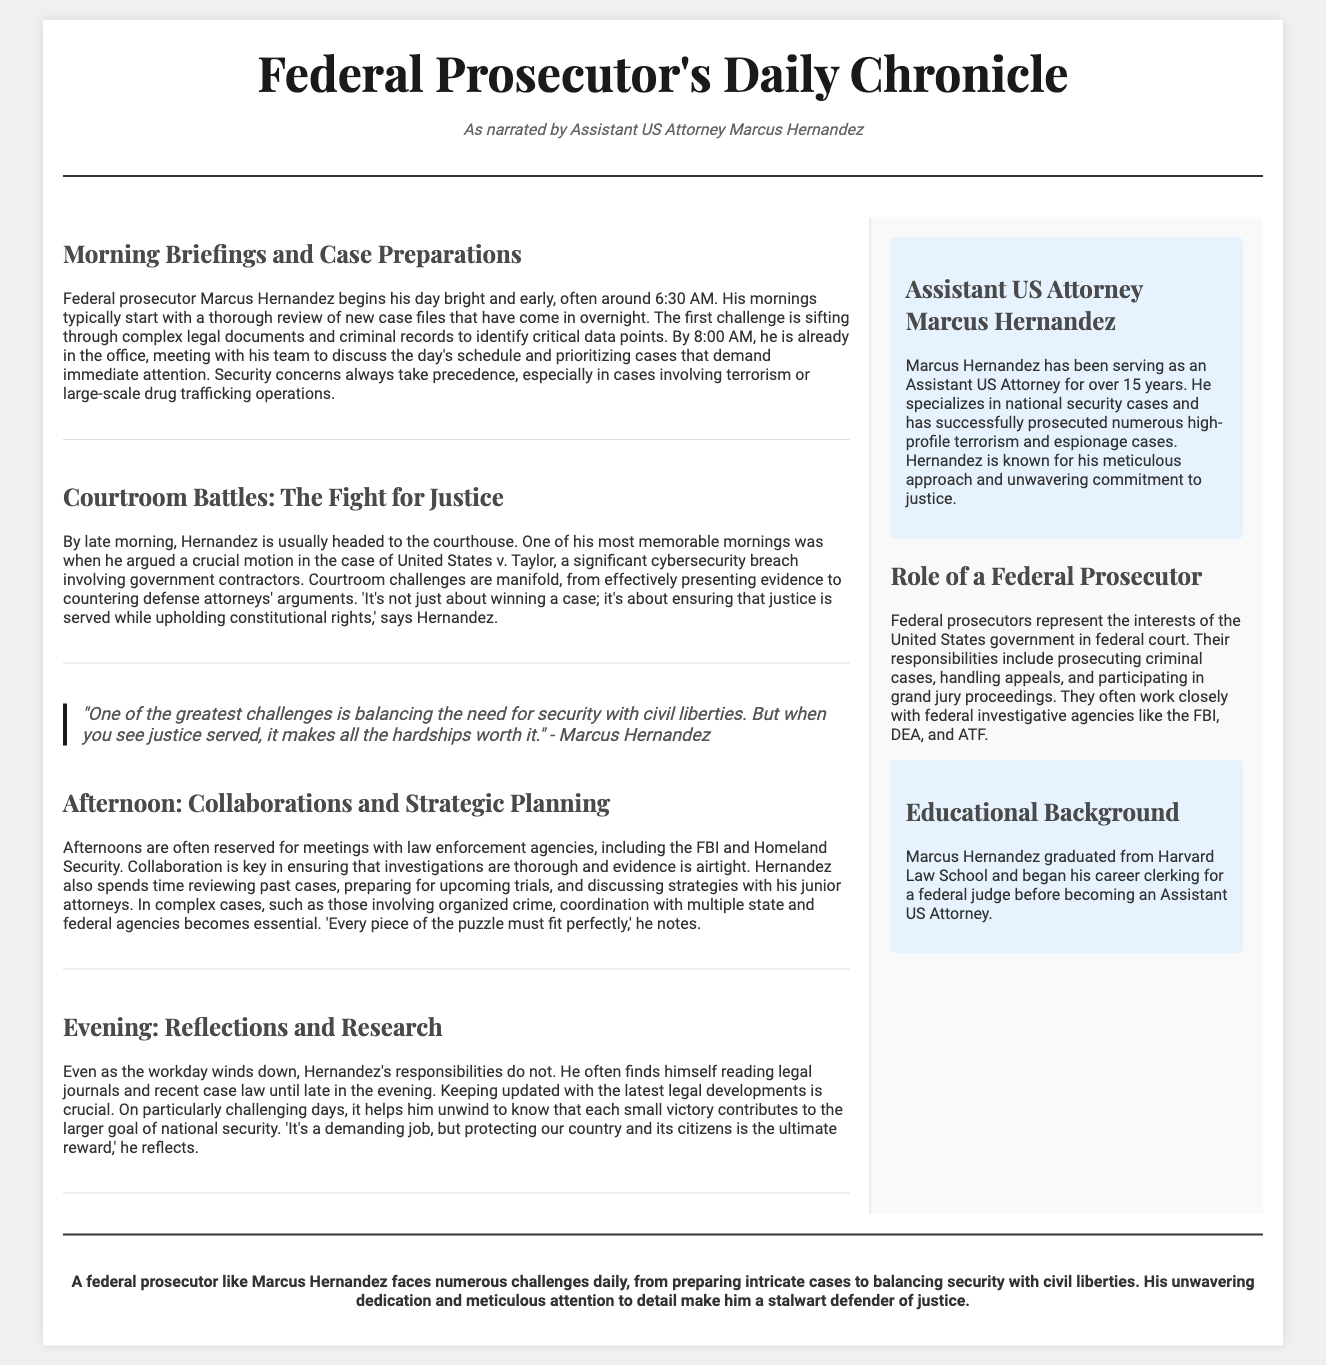What time does Marcus Hernandez start his day? The document states that Marcus Hernandez begins his day bright and early, often around 6:30 AM.
Answer: 6:30 AM What case did Hernandez argue in the courthouse? The document mentions that he argued a crucial motion in the case of United States v. Taylor.
Answer: United States v. Taylor What is the primary focus of Hernandez’s afternoon meetings? The document indicates that afternoons are often reserved for meetings with law enforcement agencies, emphasizing thorough investigations.
Answer: Collaboration with law enforcement agencies How long has Marcus Hernandez been serving as an Assistant US Attorney? The sidebar mentions that he has been serving for over 15 years.
Answer: Over 15 years What significant issue does Hernandez face as a federal prosecutor? The document highlights that balancing the need for security with civil liberties is one of his greatest challenges.
Answer: Balancing security with civil liberties What does Hernandez do to keep updated with legal developments? The document indicates that he often finds himself reading legal journals and recent case law until late in the evening.
Answer: Reading legal journals What educational institution did Marcus Hernandez graduate from? The document indicates that he graduated from Harvard Law School.
Answer: Harvard Law School What is one of Hernandez's notable characteristics as a prosecutor? The sidebar states that he is known for his meticulous approach and unwavering commitment to justice.
Answer: Meticulous approach 